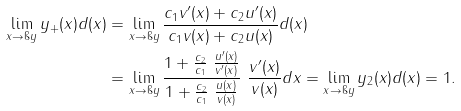<formula> <loc_0><loc_0><loc_500><loc_500>\lim _ { x \to \i y } y _ { + } ( x ) d ( x ) & = \lim _ { x \to \i y } \frac { c _ { 1 } v ^ { \prime } ( x ) + c _ { 2 } u ^ { \prime } ( x ) } { c _ { 1 } v ( x ) + c _ { 2 } u ( x ) } d ( x ) \\ & = \lim _ { x \to \i y } \frac { 1 + \frac { c _ { 2 } } { c _ { 1 } } \ \frac { u ^ { \prime } ( x ) } { v ^ { \prime } ( x ) } } { 1 + \frac { c _ { 2 } } { c _ { 1 } } \ \frac { u ( x ) } { v ( x ) } } \ \frac { v ^ { \prime } ( x ) } { v ( x ) } d x = \lim _ { x \to \i y } y _ { 2 } ( x ) d ( x ) = 1 .</formula> 